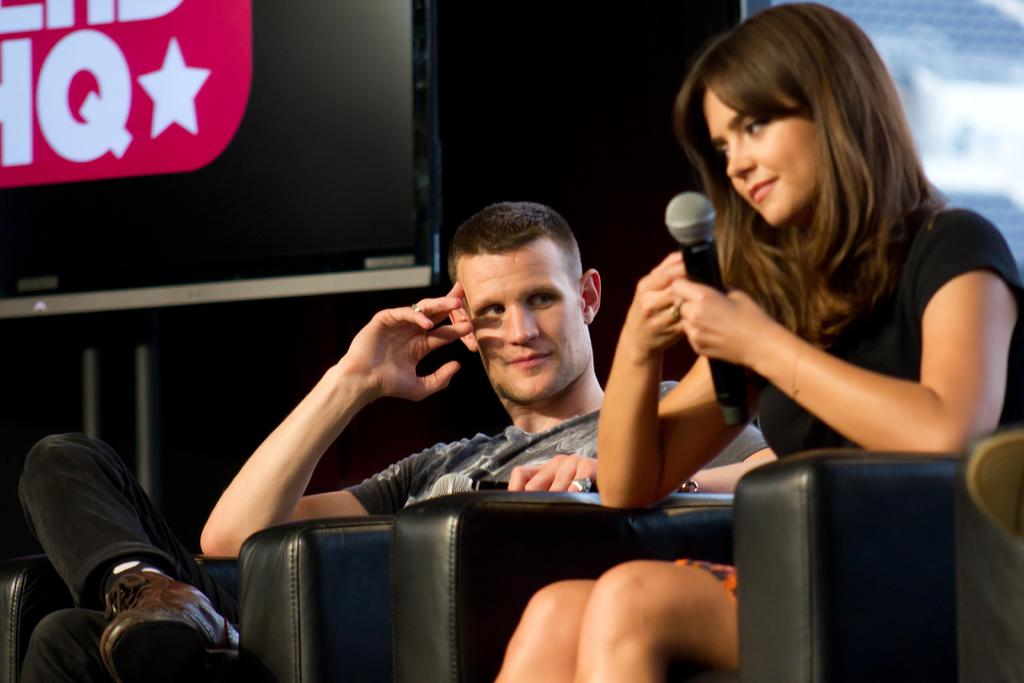Who are the people in the image? There is a man and a woman in the image. What are the positions of the man and woman in the image? Both the man and woman are seated. What is the woman holding in the image? The woman is holding a microphone. What can be seen behind the man and woman in the image? There is a screen visible in the image. What type of objects are present in the image that are made of metal? Metal rods are present in the image. How much weight does the man in the image need to lose? There is no information about the man's weight or any need for him to lose weight in the image. 